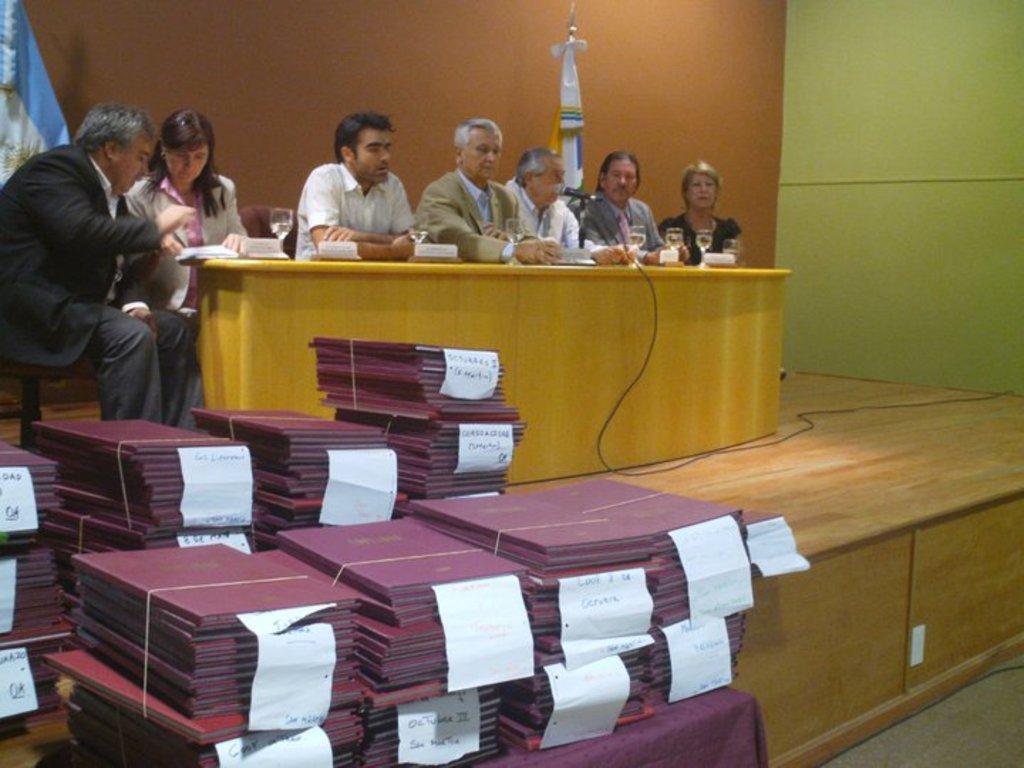Can you describe this image briefly? To the bottom left of the image there are many maroon files with papers. Behind the files there is a stage. On the stage there are few people sitting. And in front of them there is a table with name boards, glasses and also there is a mic. And in the background there is a wall. And to the right corner of the image there is a green wall. 